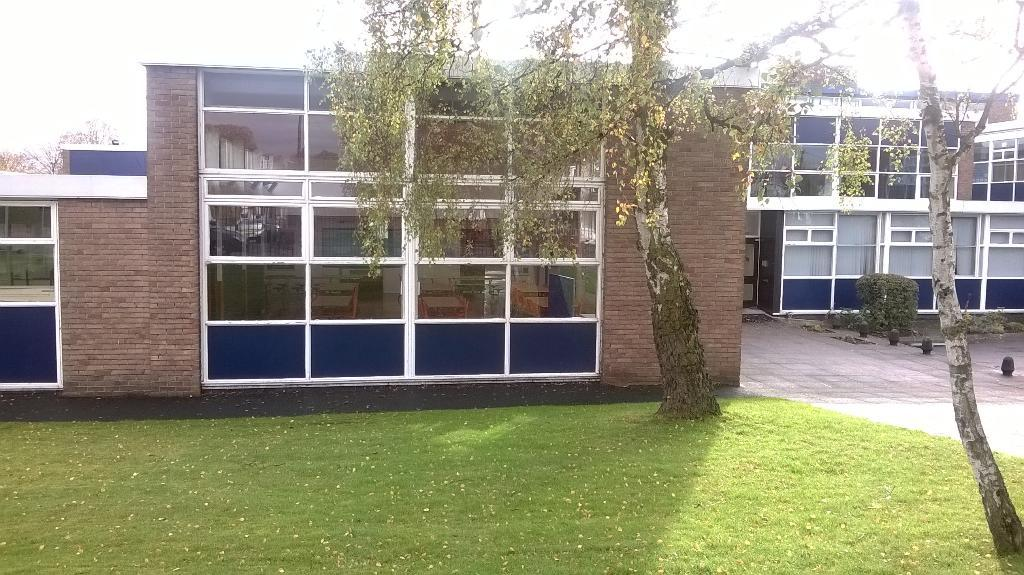What type of vegetation is visible in the image? There is grass, trees, and plants visible in the image. Can you describe the natural environment in the image? The natural environment includes grass, trees, and plants. What type of structure can be seen in the image? There is a building in the image. What else can be observed in the image? There are shadows visible in the image. What type of flame can be seen coming from the cent in the image? There is no cent or flame present in the image. How does the toothpaste affect the plants in the image? There is no toothpaste present in the image, so it cannot affect the plants. 